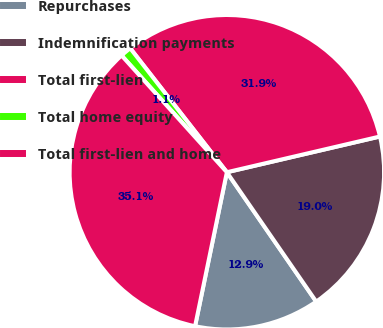<chart> <loc_0><loc_0><loc_500><loc_500><pie_chart><fcel>Repurchases<fcel>Indemnification payments<fcel>Total first-lien<fcel>Total home equity<fcel>Total first-lien and home<nl><fcel>12.86%<fcel>19.03%<fcel>31.89%<fcel>1.14%<fcel>35.08%<nl></chart> 